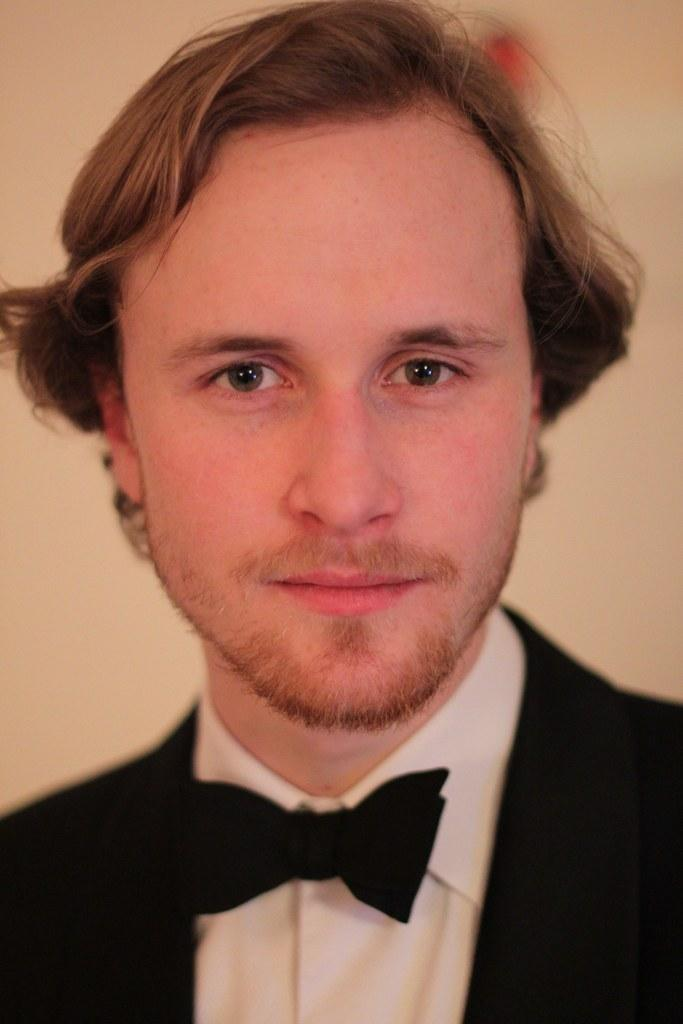What is the main subject of the image? The main subject of the image is a man. What is the man wearing in the image? The man is wearing a black jacket. What can be seen in the background of the image? There is a wall in the image. What type of brass instrument is the man playing in the image? There is no brass instrument present in the image, and the man is not playing any musical instrument. How many boots can be seen on the man's feet in the image? The man is not wearing any boots in the image; he is wearing a black jacket. 